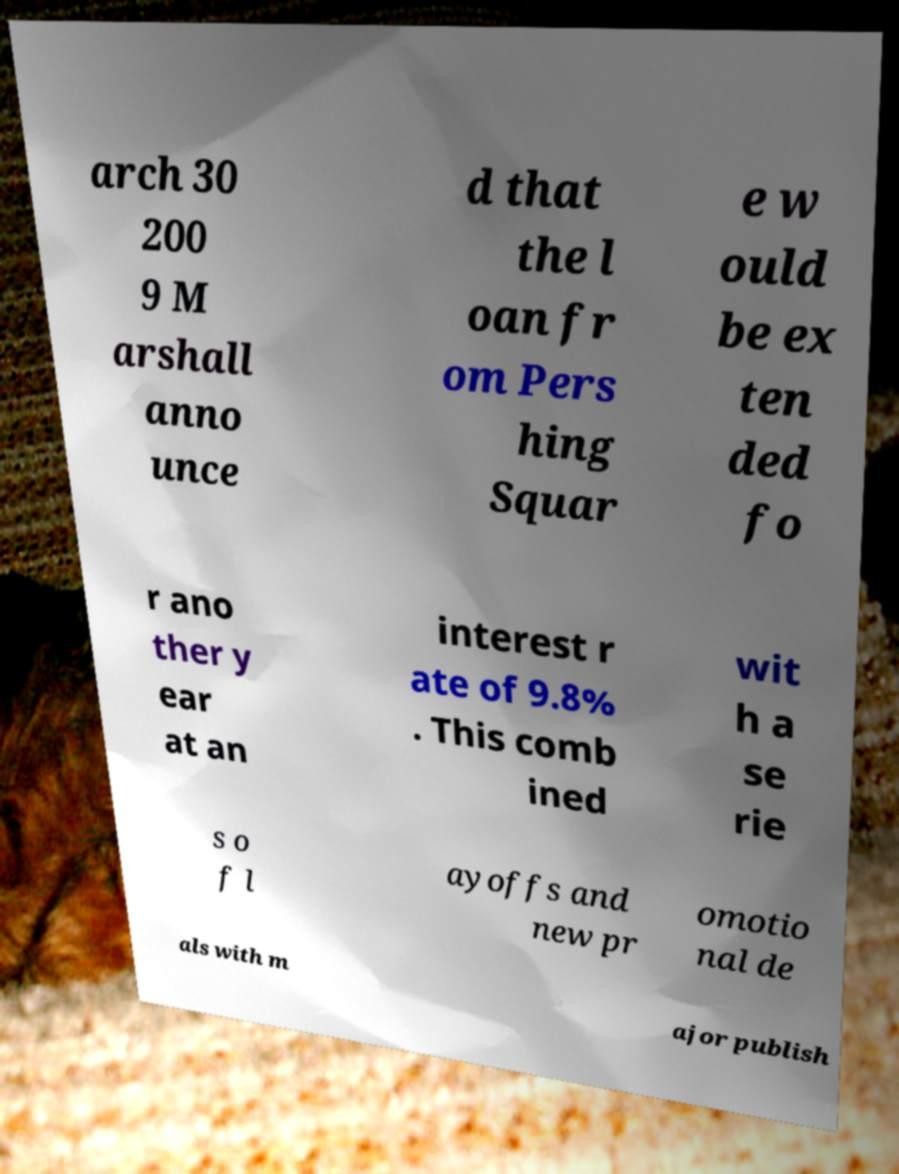Could you extract and type out the text from this image? arch 30 200 9 M arshall anno unce d that the l oan fr om Pers hing Squar e w ould be ex ten ded fo r ano ther y ear at an interest r ate of 9.8% . This comb ined wit h a se rie s o f l ayoffs and new pr omotio nal de als with m ajor publish 